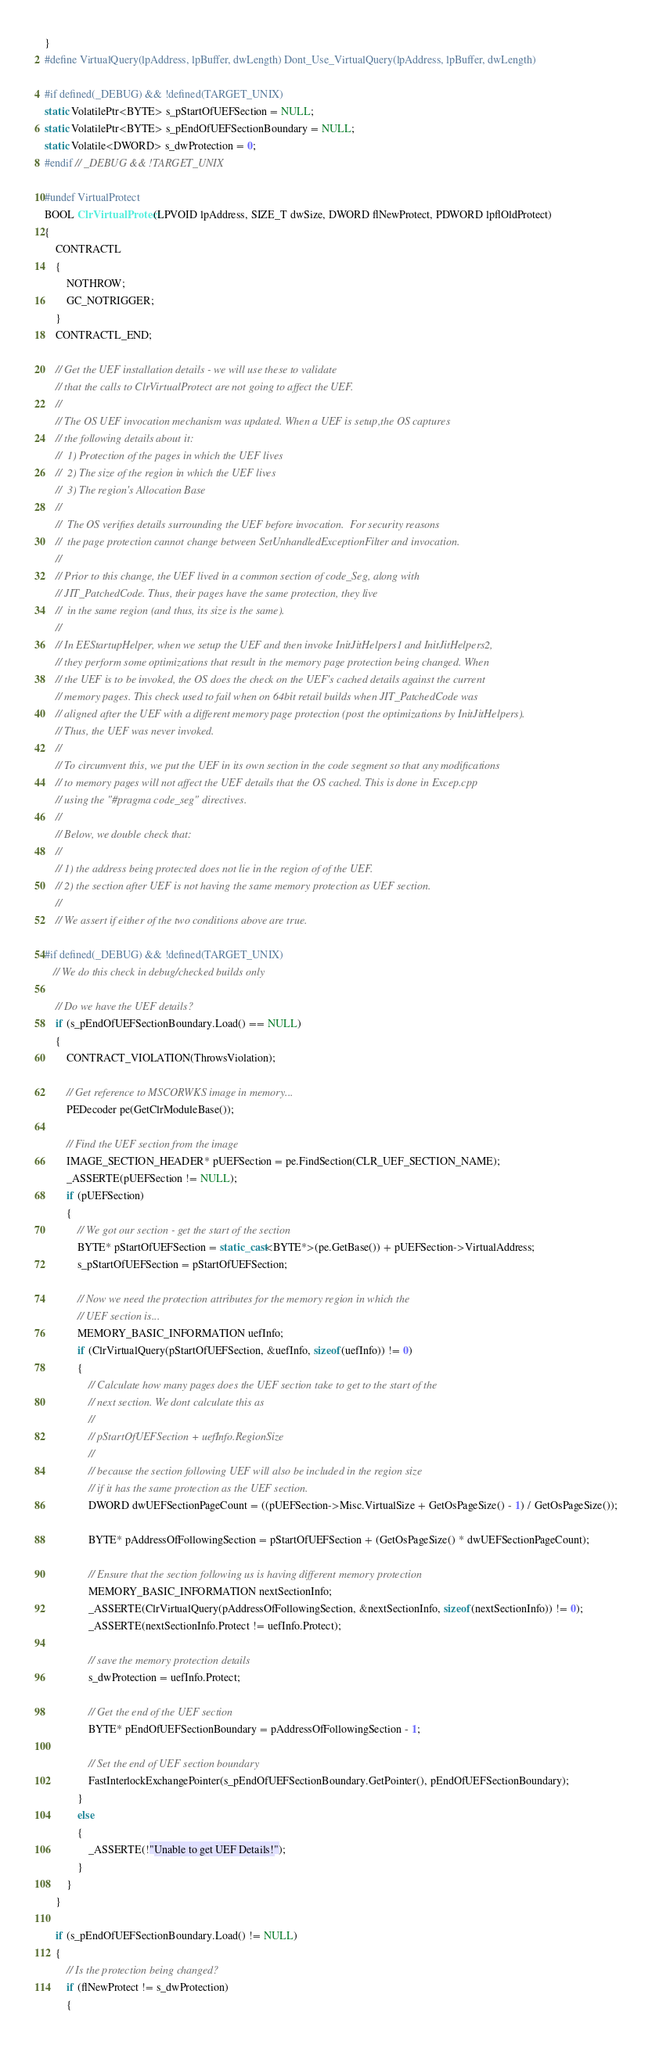Convert code to text. <code><loc_0><loc_0><loc_500><loc_500><_C++_>}
#define VirtualQuery(lpAddress, lpBuffer, dwLength) Dont_Use_VirtualQuery(lpAddress, lpBuffer, dwLength)

#if defined(_DEBUG) && !defined(TARGET_UNIX)
static VolatilePtr<BYTE> s_pStartOfUEFSection = NULL;
static VolatilePtr<BYTE> s_pEndOfUEFSectionBoundary = NULL;
static Volatile<DWORD> s_dwProtection = 0;
#endif // _DEBUG && !TARGET_UNIX

#undef VirtualProtect
BOOL ClrVirtualProtect(LPVOID lpAddress, SIZE_T dwSize, DWORD flNewProtect, PDWORD lpflOldProtect)
{
    CONTRACTL
    {
        NOTHROW;
        GC_NOTRIGGER;
    }
    CONTRACTL_END;

    // Get the UEF installation details - we will use these to validate
    // that the calls to ClrVirtualProtect are not going to affect the UEF.
    //
    // The OS UEF invocation mechanism was updated. When a UEF is setup,the OS captures
    // the following details about it:
    //  1) Protection of the pages in which the UEF lives
    //  2) The size of the region in which the UEF lives
    //  3) The region's Allocation Base
    //
    //  The OS verifies details surrounding the UEF before invocation.  For security reasons
    //  the page protection cannot change between SetUnhandledExceptionFilter and invocation.
    //
    // Prior to this change, the UEF lived in a common section of code_Seg, along with
    // JIT_PatchedCode. Thus, their pages have the same protection, they live
    //  in the same region (and thus, its size is the same).
    //
    // In EEStartupHelper, when we setup the UEF and then invoke InitJitHelpers1 and InitJitHelpers2,
    // they perform some optimizations that result in the memory page protection being changed. When
    // the UEF is to be invoked, the OS does the check on the UEF's cached details against the current
    // memory pages. This check used to fail when on 64bit retail builds when JIT_PatchedCode was
    // aligned after the UEF with a different memory page protection (post the optimizations by InitJitHelpers).
    // Thus, the UEF was never invoked.
    //
    // To circumvent this, we put the UEF in its own section in the code segment so that any modifications
    // to memory pages will not affect the UEF details that the OS cached. This is done in Excep.cpp
    // using the "#pragma code_seg" directives.
    //
    // Below, we double check that:
    //
    // 1) the address being protected does not lie in the region of of the UEF.
    // 2) the section after UEF is not having the same memory protection as UEF section.
    //
    // We assert if either of the two conditions above are true.

#if defined(_DEBUG) && !defined(TARGET_UNIX)
   // We do this check in debug/checked builds only

    // Do we have the UEF details?
    if (s_pEndOfUEFSectionBoundary.Load() == NULL)
    {
        CONTRACT_VIOLATION(ThrowsViolation);

        // Get reference to MSCORWKS image in memory...
        PEDecoder pe(GetClrModuleBase());

        // Find the UEF section from the image
        IMAGE_SECTION_HEADER* pUEFSection = pe.FindSection(CLR_UEF_SECTION_NAME);
        _ASSERTE(pUEFSection != NULL);
        if (pUEFSection)
        {
            // We got our section - get the start of the section
            BYTE* pStartOfUEFSection = static_cast<BYTE*>(pe.GetBase()) + pUEFSection->VirtualAddress;
            s_pStartOfUEFSection = pStartOfUEFSection;

            // Now we need the protection attributes for the memory region in which the
            // UEF section is...
            MEMORY_BASIC_INFORMATION uefInfo;
            if (ClrVirtualQuery(pStartOfUEFSection, &uefInfo, sizeof(uefInfo)) != 0)
            {
                // Calculate how many pages does the UEF section take to get to the start of the
                // next section. We dont calculate this as
                //
                // pStartOfUEFSection + uefInfo.RegionSize
                //
                // because the section following UEF will also be included in the region size
                // if it has the same protection as the UEF section.
                DWORD dwUEFSectionPageCount = ((pUEFSection->Misc.VirtualSize + GetOsPageSize() - 1) / GetOsPageSize());

                BYTE* pAddressOfFollowingSection = pStartOfUEFSection + (GetOsPageSize() * dwUEFSectionPageCount);

                // Ensure that the section following us is having different memory protection
                MEMORY_BASIC_INFORMATION nextSectionInfo;
                _ASSERTE(ClrVirtualQuery(pAddressOfFollowingSection, &nextSectionInfo, sizeof(nextSectionInfo)) != 0);
                _ASSERTE(nextSectionInfo.Protect != uefInfo.Protect);

                // save the memory protection details
                s_dwProtection = uefInfo.Protect;

                // Get the end of the UEF section
                BYTE* pEndOfUEFSectionBoundary = pAddressOfFollowingSection - 1;

                // Set the end of UEF section boundary
                FastInterlockExchangePointer(s_pEndOfUEFSectionBoundary.GetPointer(), pEndOfUEFSectionBoundary);
            }
            else
            {
                _ASSERTE(!"Unable to get UEF Details!");
            }
        }
    }

    if (s_pEndOfUEFSectionBoundary.Load() != NULL)
    {
        // Is the protection being changed?
        if (flNewProtect != s_dwProtection)
        {</code> 